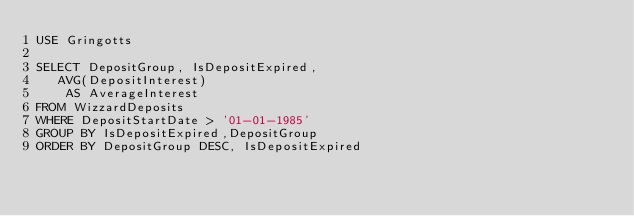<code> <loc_0><loc_0><loc_500><loc_500><_SQL_>USE Gringotts

SELECT DepositGroup, IsDepositExpired, 
   AVG(DepositInterest) 
    AS AverageInterest
FROM WizzardDeposits
WHERE DepositStartDate > '01-01-1985'
GROUP BY IsDepositExpired,DepositGroup
ORDER BY DepositGroup DESC, IsDepositExpired</code> 